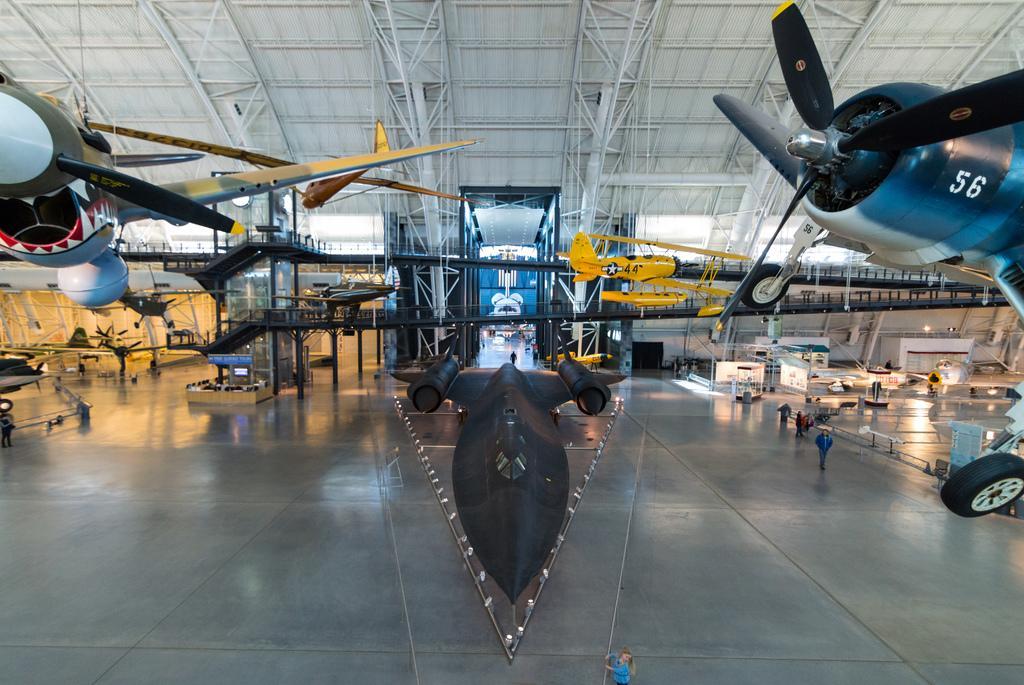How would you summarize this image in a sentence or two? In this image I can see a black colored aircraft on the ground. I can see few other air crafts, few persons standing on the ground , the ceiling, few air crafts in the air , few metal rods to the ceiling and in the background I can see few lights and few other objects. 